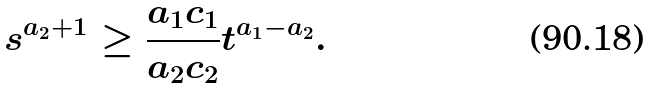Convert formula to latex. <formula><loc_0><loc_0><loc_500><loc_500>s ^ { a _ { 2 } + 1 } \geq \frac { a _ { 1 } c _ { 1 } } { a _ { 2 } c _ { 2 } } t ^ { a _ { 1 } - a _ { 2 } } .</formula> 